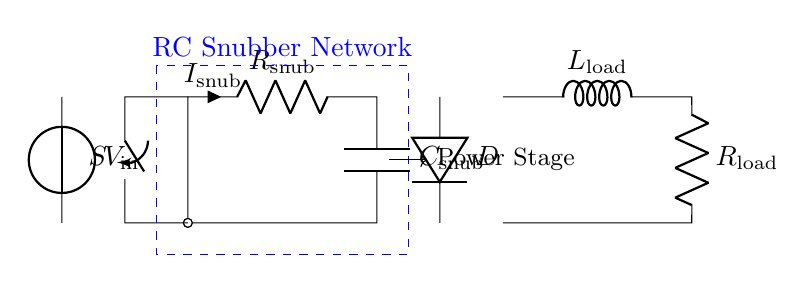What is the purpose of the RC snubber network? The RC snubber network is used to protect switching components by dampening voltage spikes and reducing electromagnetic interference during switching events.
Answer: Protect switching components What is the value of the load resistance in this circuit? The load resistance is indicated as R load in the circuit diagram, but the specific numerical value is not provided; it could depend on the application or design specifications.
Answer: R load Which component influences the decline in voltage across the switch? The capacitor C snub plays a crucial role because it charges and discharges, influencing how quickly the voltage can change, thus affecting the switch's operation during transitions.
Answer: C snub What happens to the current when the switch is closed? When the switch S is closed, the current I snub flows through the resistor R snub and the capacitor C snub, allowing the snubber network to absorb transient energy and regulate voltage levels.
Answer: Current flows through the network What is the role of the diode in this circuit? The diode D provides a path for reverse current, preventing back EMF from the inductive load L load from damaging other components in the circuit during sudden changes in current.
Answer: Prevents back EMF How does the inductor affect the performance of the circuit? The inductor L load stores energy in its magnetic field, contributing to the inductive kickback effect when the switch opens, necessitating proper snubbing to prevent voltage spikes.
Answer: Stores energy What type of switching component is represented in this circuit? The switch S represented in the circuit is typically a transistor or a relay, both of which are used to control power flow in electronic circuits.
Answer: Transistor or relay 